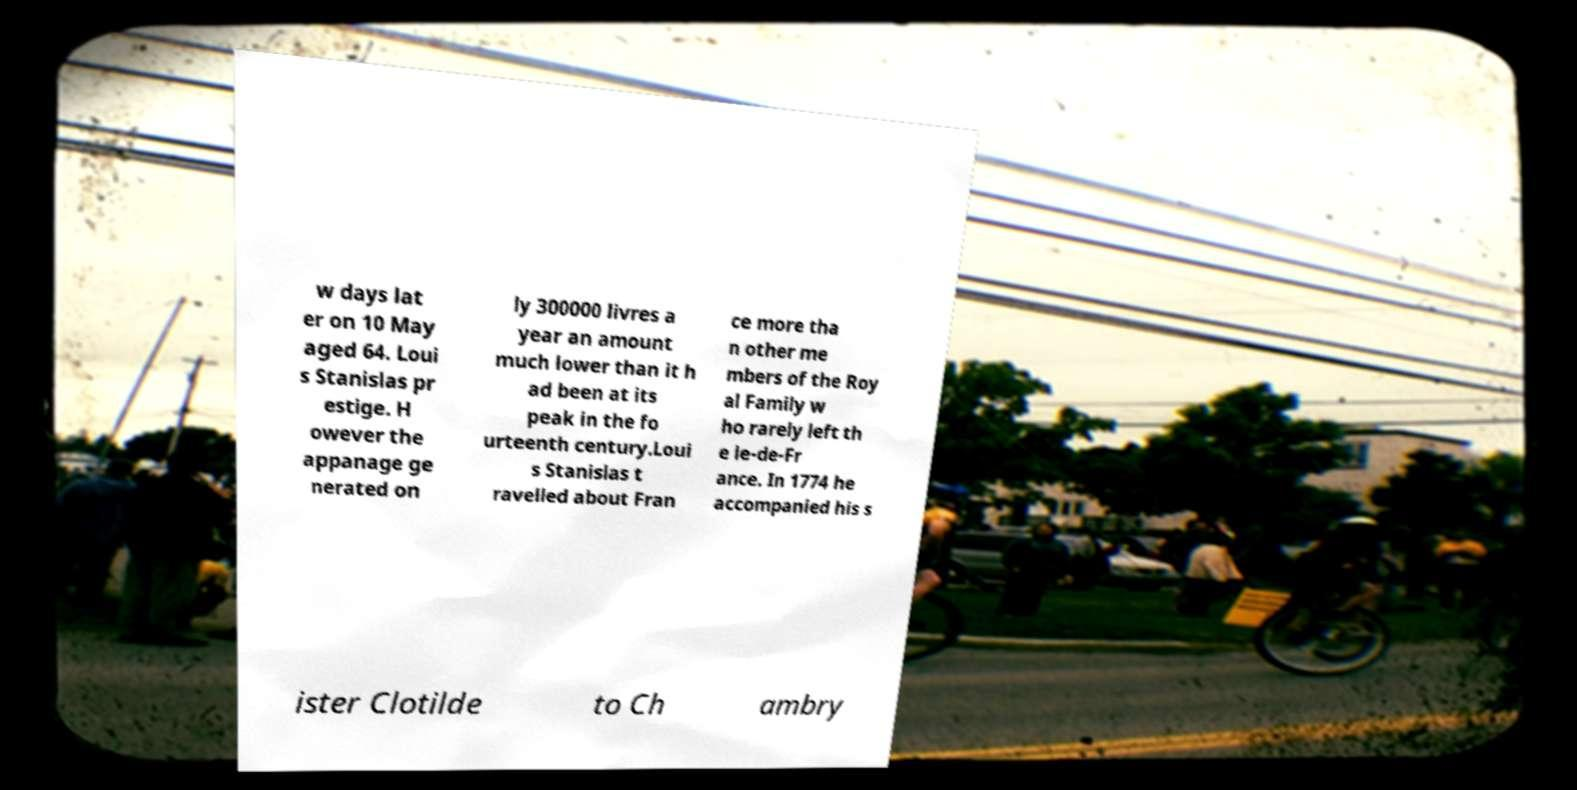Could you assist in decoding the text presented in this image and type it out clearly? w days lat er on 10 May aged 64. Loui s Stanislas pr estige. H owever the appanage ge nerated on ly 300000 livres a year an amount much lower than it h ad been at its peak in the fo urteenth century.Loui s Stanislas t ravelled about Fran ce more tha n other me mbers of the Roy al Family w ho rarely left th e le-de-Fr ance. In 1774 he accompanied his s ister Clotilde to Ch ambry 